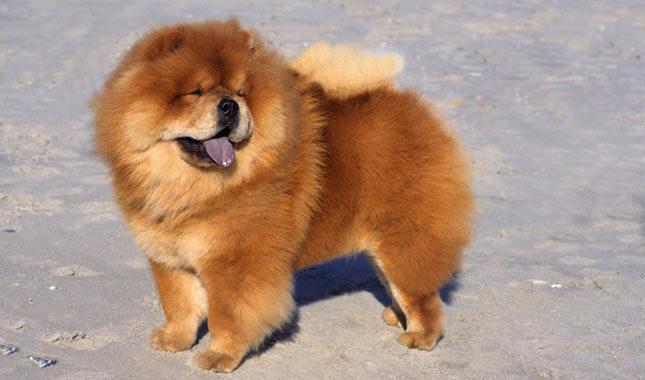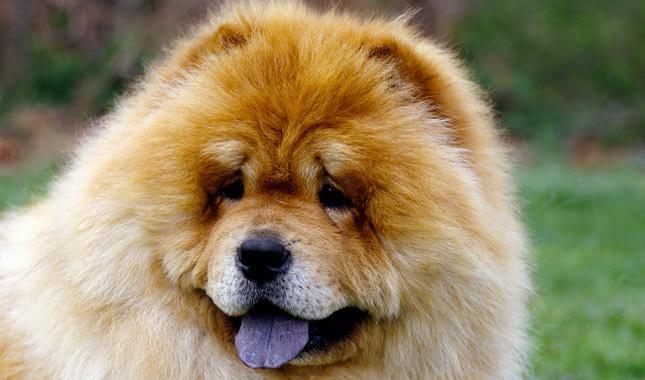The first image is the image on the left, the second image is the image on the right. For the images displayed, is the sentence "In at least one image, there’s a single dark brown dog with a purple tongue sticking out as his light brown tail sits on his back, while he stands." factually correct? Answer yes or no. Yes. The first image is the image on the left, the second image is the image on the right. Analyze the images presented: Is the assertion "in at least one image there ia a dog fully visable on the grass" valid? Answer yes or no. No. 